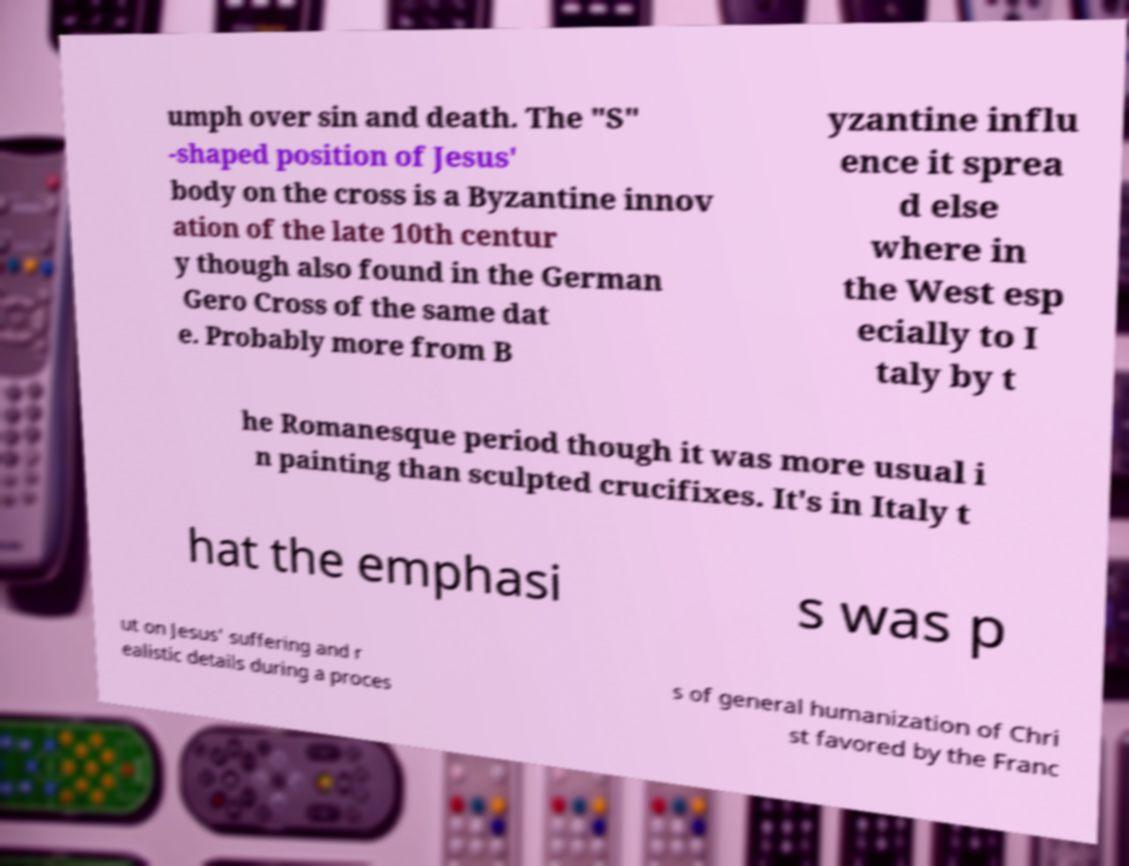Please read and relay the text visible in this image. What does it say? umph over sin and death. The "S" -shaped position of Jesus' body on the cross is a Byzantine innov ation of the late 10th centur y though also found in the German Gero Cross of the same dat e. Probably more from B yzantine influ ence it sprea d else where in the West esp ecially to I taly by t he Romanesque period though it was more usual i n painting than sculpted crucifixes. It's in Italy t hat the emphasi s was p ut on Jesus' suffering and r ealistic details during a proces s of general humanization of Chri st favored by the Franc 